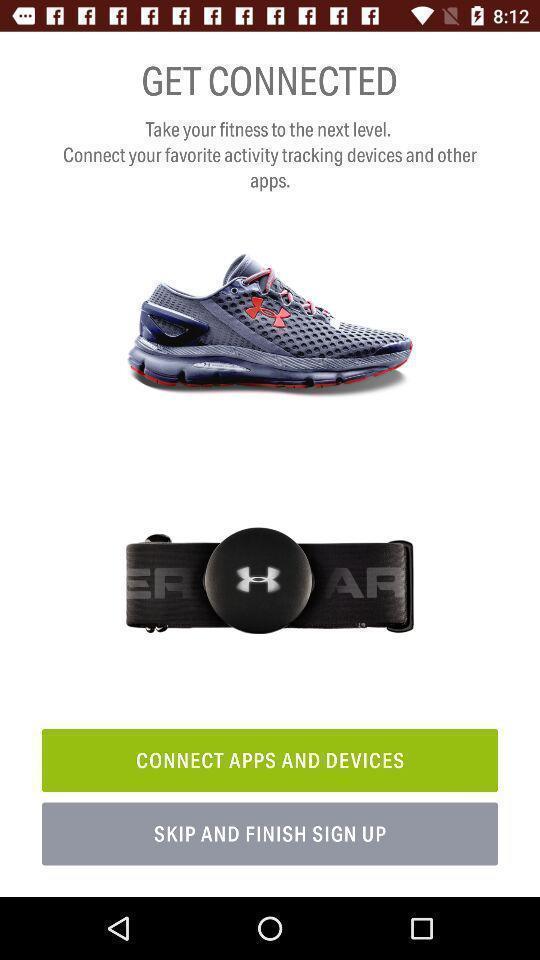Give me a summary of this screen capture. Welcome page of a fitness app. 